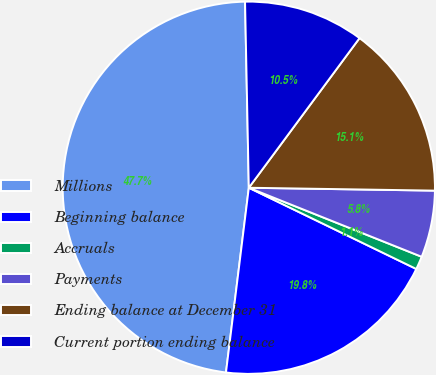Convert chart to OTSL. <chart><loc_0><loc_0><loc_500><loc_500><pie_chart><fcel>Millions<fcel>Beginning balance<fcel>Accruals<fcel>Payments<fcel>Ending balance at December 31<fcel>Current portion ending balance<nl><fcel>47.72%<fcel>19.77%<fcel>1.14%<fcel>5.8%<fcel>15.11%<fcel>10.46%<nl></chart> 